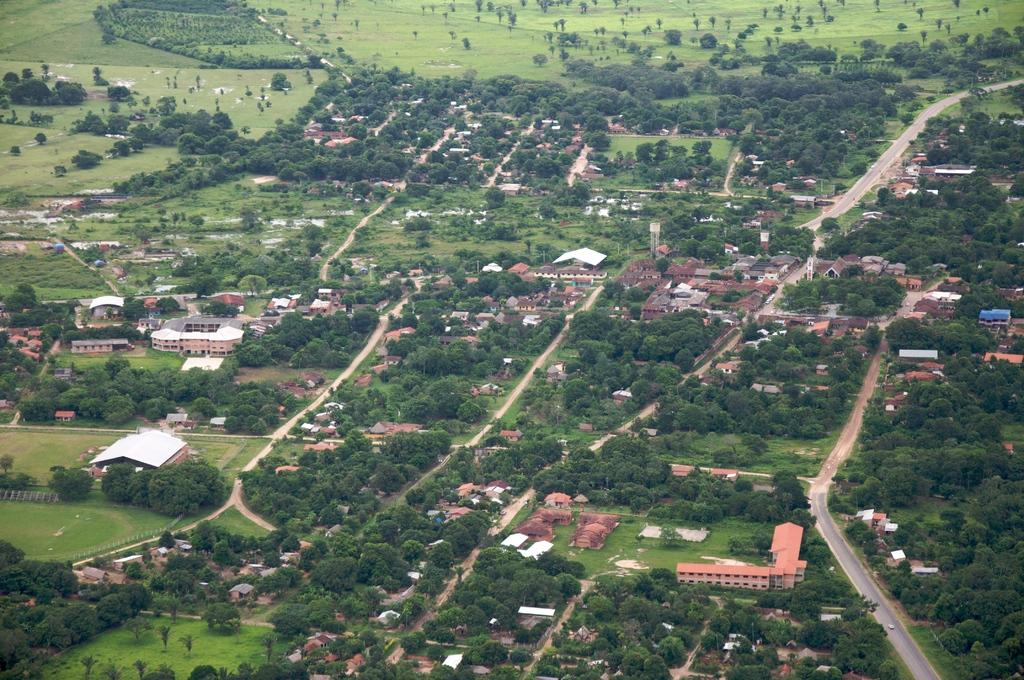What type of view is depicted in the image? The image is an aerial view. What can be seen on the ground in the image? There are roads, buildings, trees, and grasslands visible in the image. What type of treatment is being advertised in the image? There is no treatment or advertisement present in the image; it is an aerial view of a landscape with roads, buildings, trees, and grasslands. 